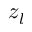<formula> <loc_0><loc_0><loc_500><loc_500>z _ { l }</formula> 